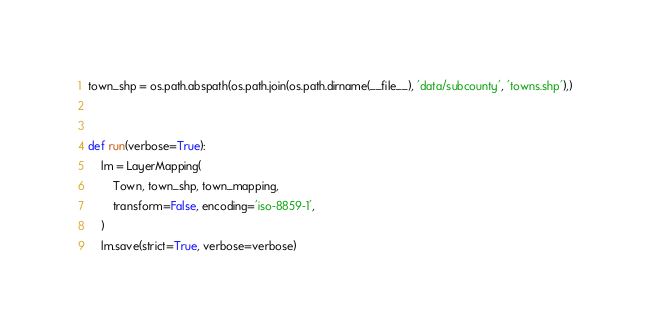Convert code to text. <code><loc_0><loc_0><loc_500><loc_500><_Python_>town_shp = os.path.abspath(os.path.join(os.path.dirname(__file__), 'data/subcounty', 'towns.shp'),)


def run(verbose=True):
    lm = LayerMapping(
        Town, town_shp, town_mapping,
        transform=False, encoding='iso-8859-1',
    )
    lm.save(strict=True, verbose=verbose)
</code> 